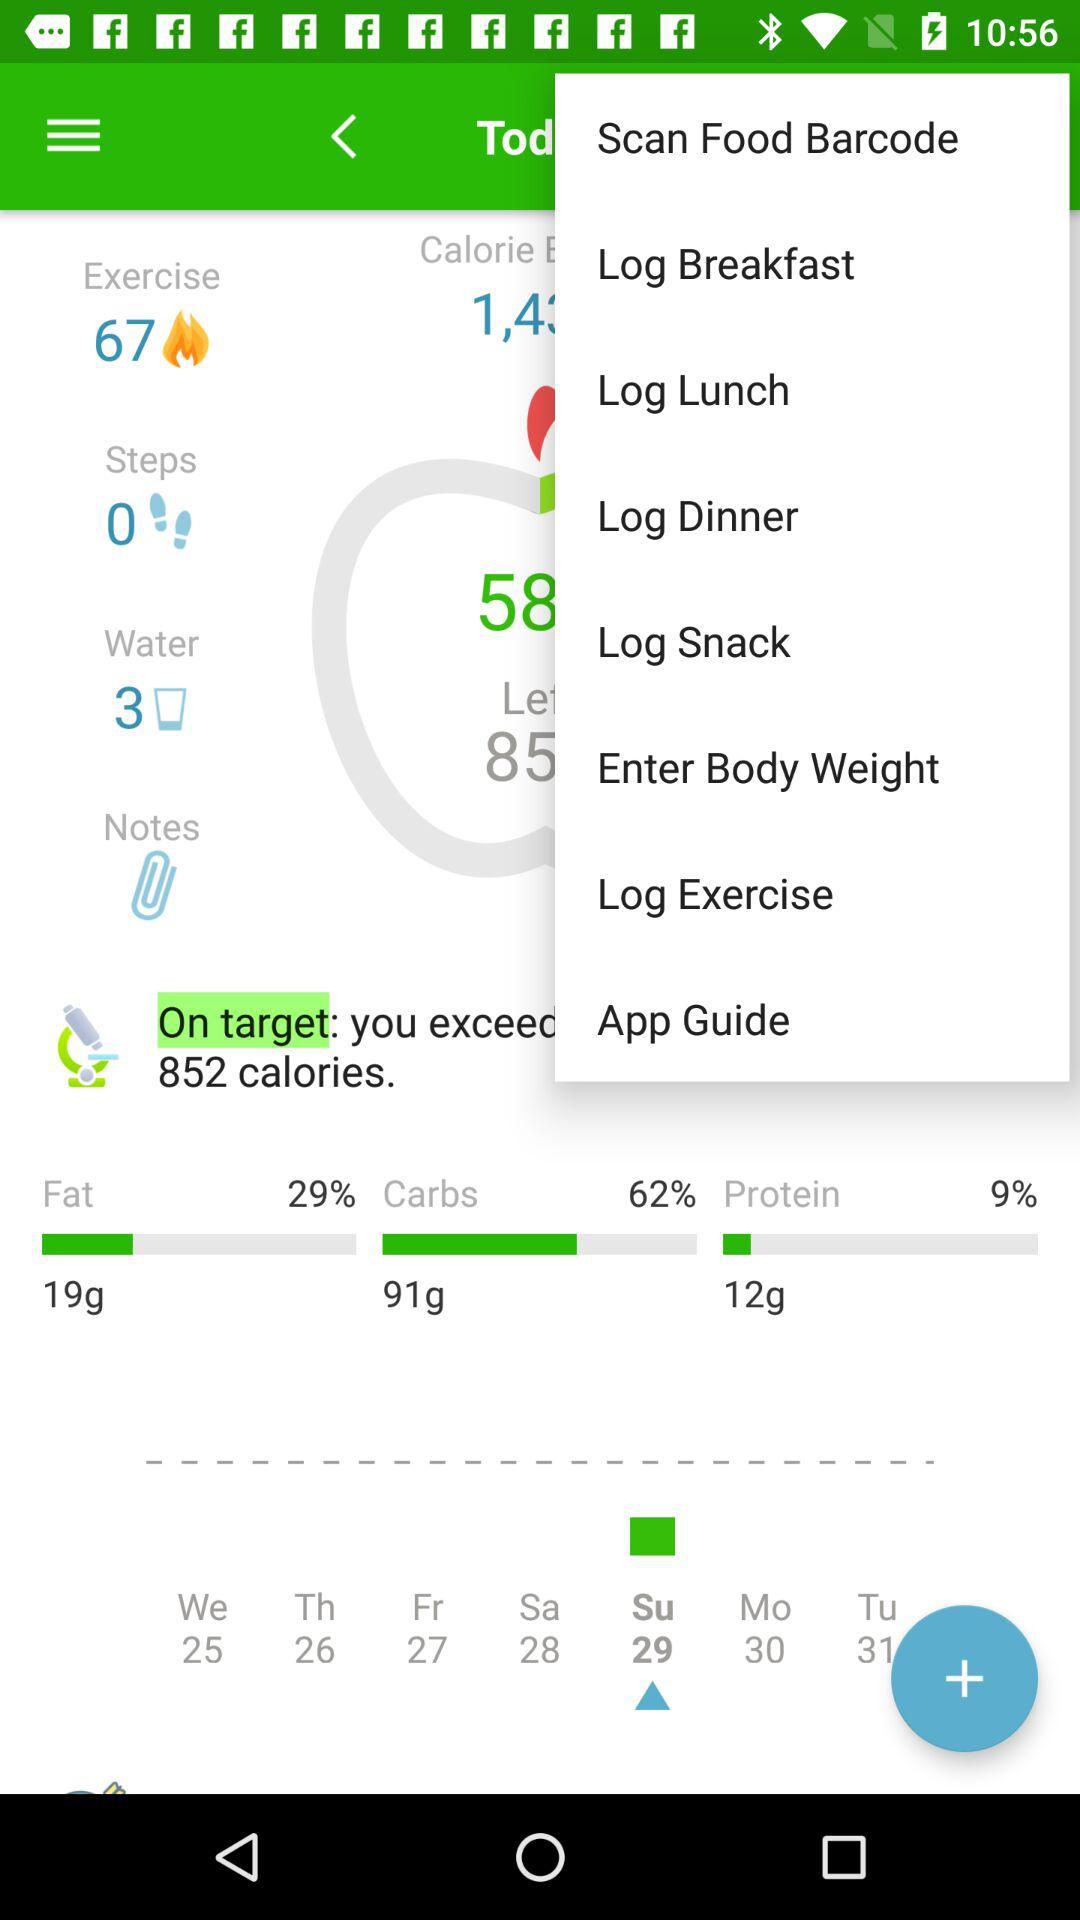What is the selected date on the calendar? The selected date is 29. 